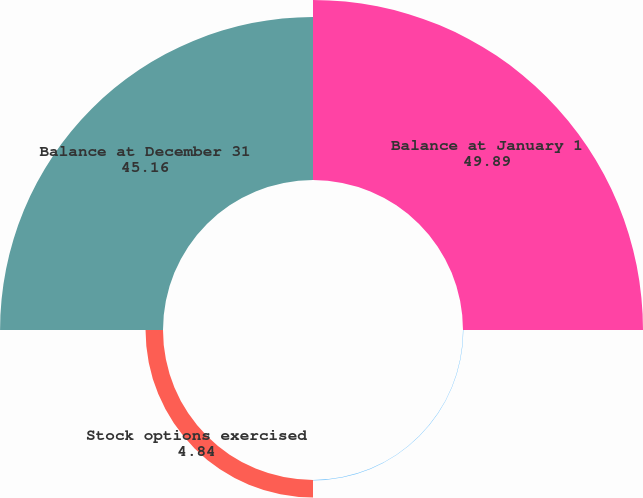<chart> <loc_0><loc_0><loc_500><loc_500><pie_chart><fcel>Balance at January 1<fcel>Activity related to restricted<fcel>Stock options exercised<fcel>Balance at December 31<nl><fcel>49.89%<fcel>0.11%<fcel>4.84%<fcel>45.16%<nl></chart> 